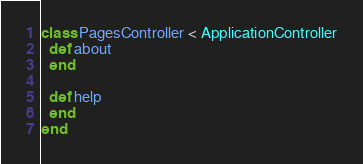<code> <loc_0><loc_0><loc_500><loc_500><_Ruby_>class PagesController < ApplicationController
  def about
  end

  def help
  end
end
</code> 